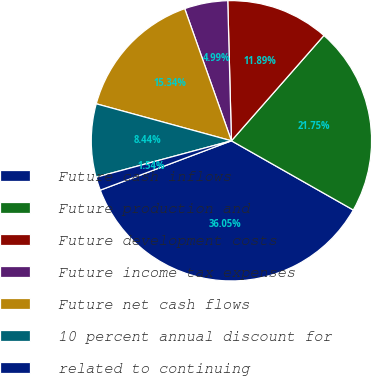Convert chart to OTSL. <chart><loc_0><loc_0><loc_500><loc_500><pie_chart><fcel>Future cash inflows<fcel>Future production and<fcel>Future development costs<fcel>Future income tax expenses<fcel>Future net cash flows<fcel>10 percent annual discount for<fcel>related to continuing<nl><fcel>36.05%<fcel>21.75%<fcel>11.89%<fcel>4.99%<fcel>15.34%<fcel>8.44%<fcel>1.54%<nl></chart> 